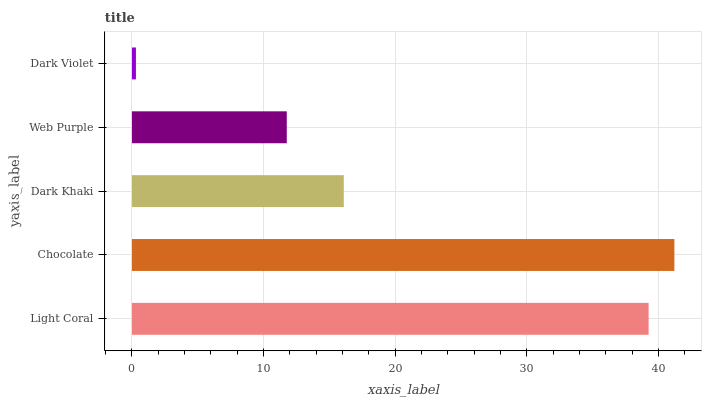Is Dark Violet the minimum?
Answer yes or no. Yes. Is Chocolate the maximum?
Answer yes or no. Yes. Is Dark Khaki the minimum?
Answer yes or no. No. Is Dark Khaki the maximum?
Answer yes or no. No. Is Chocolate greater than Dark Khaki?
Answer yes or no. Yes. Is Dark Khaki less than Chocolate?
Answer yes or no. Yes. Is Dark Khaki greater than Chocolate?
Answer yes or no. No. Is Chocolate less than Dark Khaki?
Answer yes or no. No. Is Dark Khaki the high median?
Answer yes or no. Yes. Is Dark Khaki the low median?
Answer yes or no. Yes. Is Light Coral the high median?
Answer yes or no. No. Is Web Purple the low median?
Answer yes or no. No. 